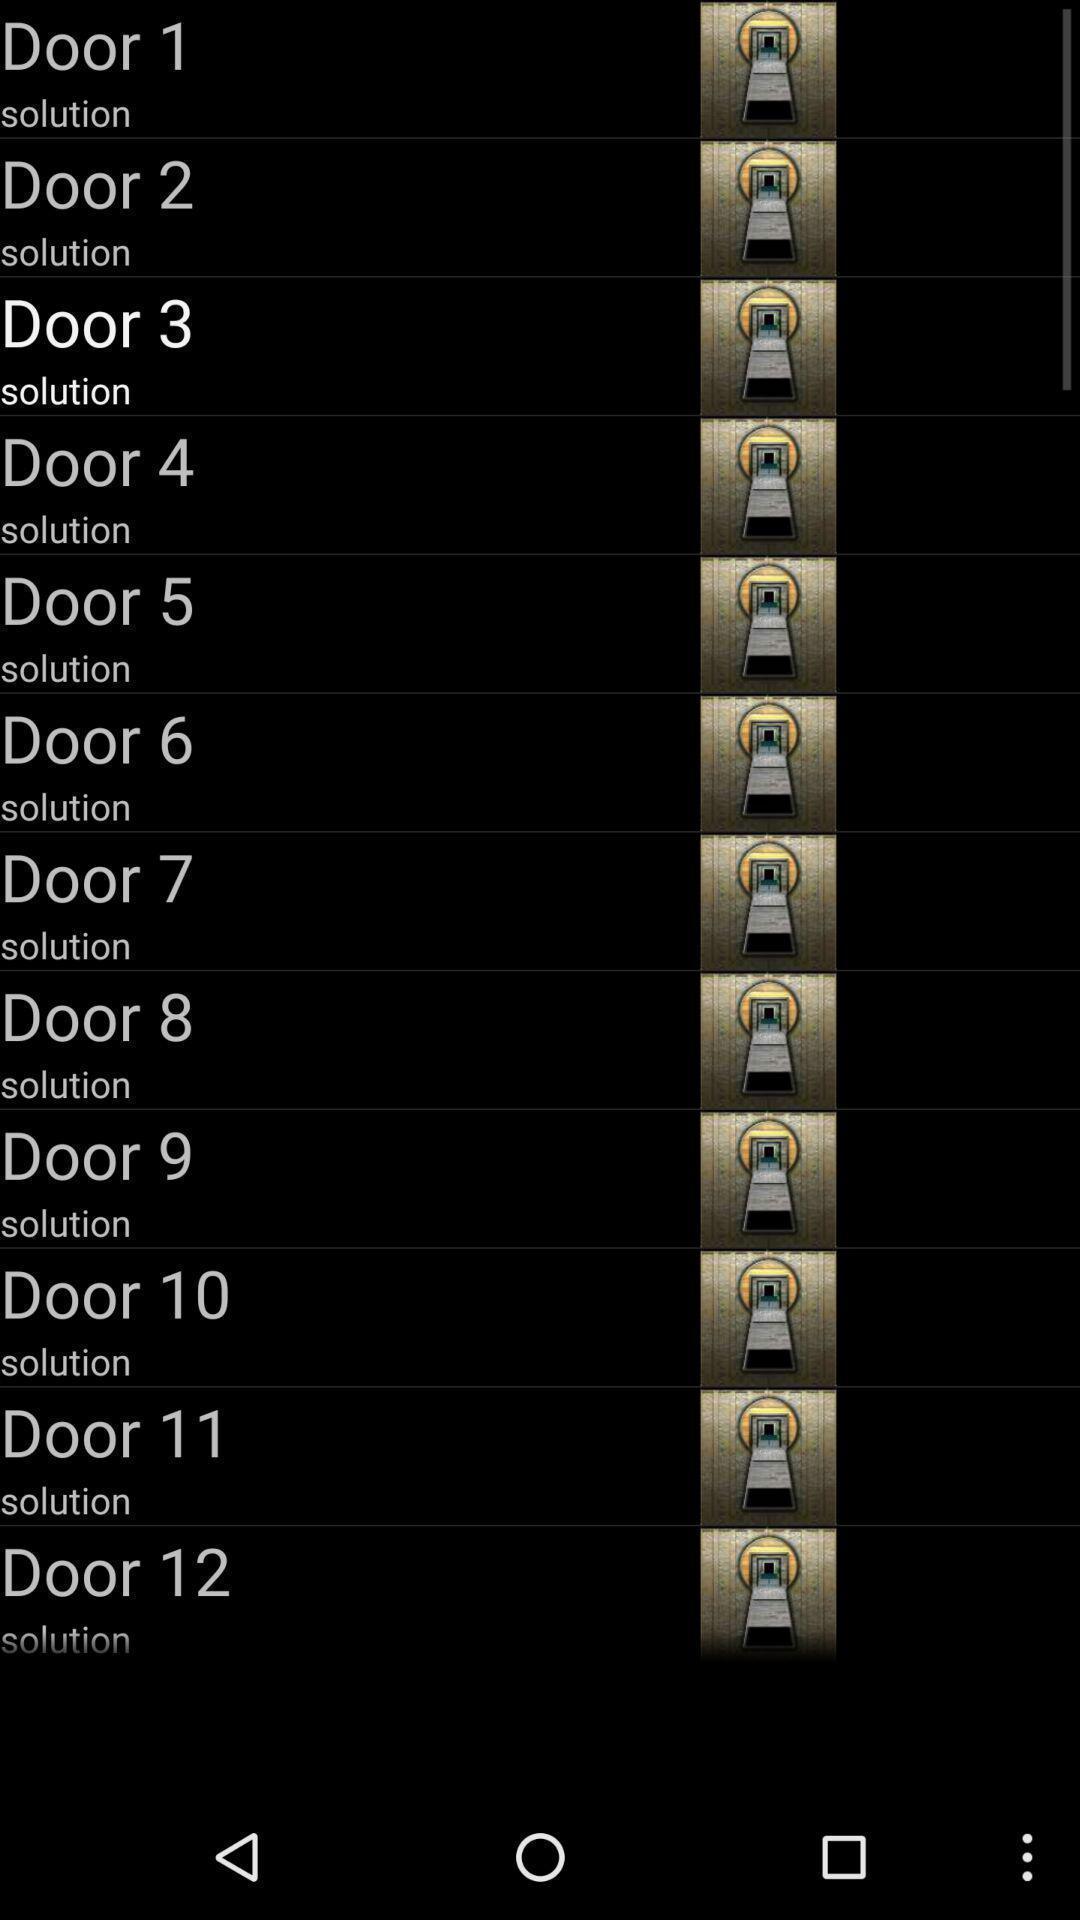Please provide a description for this image. Page displaying the multiple options in app. 